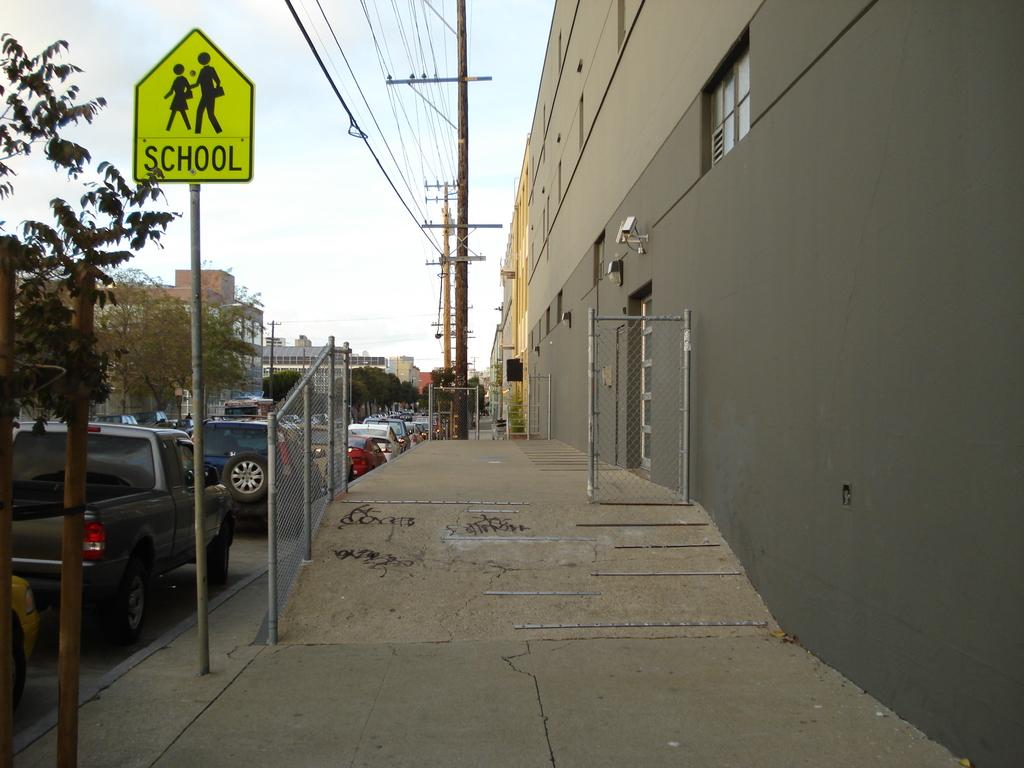What kind of place is near hear?
Offer a very short reply. School. 